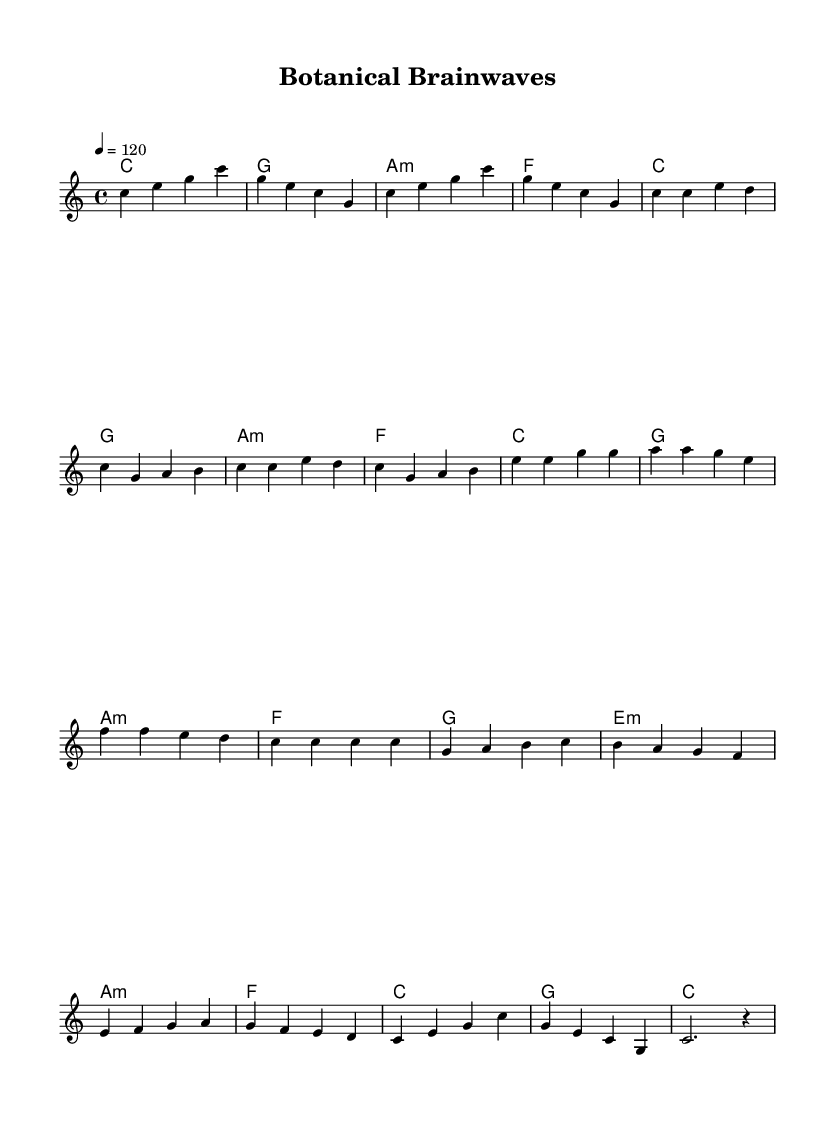What is the key signature of this music? The key signature is indicated by the first part of the global settings. It shows there are no sharps or flats, which defines C major.
Answer: C major What is the time signature of this piece? The time signature is located in the global section of the code, where it is specified as 4/4. This means there are four beats in a measure and the quarter note gets one beat.
Answer: 4/4 What is the tempo marking given in the sheet music? The tempo is defined in the global settings as 4 = 120, indicating that there are 120 quarter note beats per minute.
Answer: 120 How many sections are in the structure of the piece? By analyzing the melody part, we can determine that there are five identifiable sections: Intro, Verse, Chorus, Bridge, and Outro.
Answer: 5 What type of harmony is primarily used in the chorus section? In the chorus, the harmony is made up of major and minor chords primarily, specifically using C major, G major, A minor, and F major.
Answer: Major and minor What is the last note of the melody before the piece ends? The last note is found in the Outro section of the melody, where it concludes with a single quarter note C, and a rest afterward.
Answer: C What is a distinct feature of the musical style represented in this sheet music? The use of melodic patterns combined with harmonic progressions supports a meditation or concentration ambiance, which aligns with the electronic music with binaural beats intended to enhance focus.
Answer: Meditation ambiance 